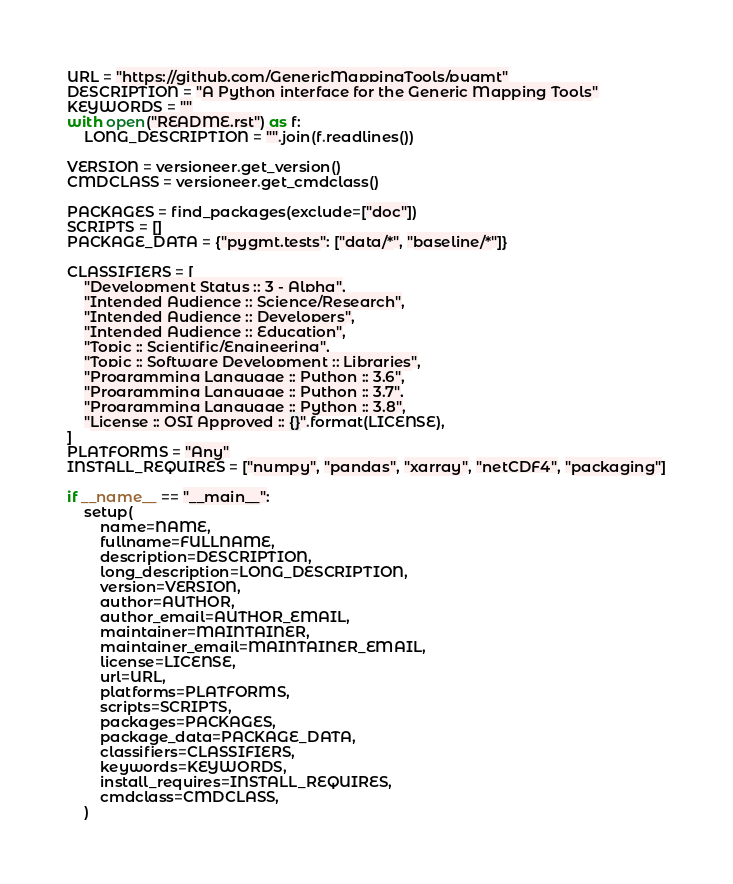<code> <loc_0><loc_0><loc_500><loc_500><_Python_>URL = "https://github.com/GenericMappingTools/pygmt"
DESCRIPTION = "A Python interface for the Generic Mapping Tools"
KEYWORDS = ""
with open("README.rst") as f:
    LONG_DESCRIPTION = "".join(f.readlines())

VERSION = versioneer.get_version()
CMDCLASS = versioneer.get_cmdclass()

PACKAGES = find_packages(exclude=["doc"])
SCRIPTS = []
PACKAGE_DATA = {"pygmt.tests": ["data/*", "baseline/*"]}

CLASSIFIERS = [
    "Development Status :: 3 - Alpha",
    "Intended Audience :: Science/Research",
    "Intended Audience :: Developers",
    "Intended Audience :: Education",
    "Topic :: Scientific/Engineering",
    "Topic :: Software Development :: Libraries",
    "Programming Language :: Python :: 3.6",
    "Programming Language :: Python :: 3.7",
    "Programming Language :: Python :: 3.8",
    "License :: OSI Approved :: {}".format(LICENSE),
]
PLATFORMS = "Any"
INSTALL_REQUIRES = ["numpy", "pandas", "xarray", "netCDF4", "packaging"]

if __name__ == "__main__":
    setup(
        name=NAME,
        fullname=FULLNAME,
        description=DESCRIPTION,
        long_description=LONG_DESCRIPTION,
        version=VERSION,
        author=AUTHOR,
        author_email=AUTHOR_EMAIL,
        maintainer=MAINTAINER,
        maintainer_email=MAINTAINER_EMAIL,
        license=LICENSE,
        url=URL,
        platforms=PLATFORMS,
        scripts=SCRIPTS,
        packages=PACKAGES,
        package_data=PACKAGE_DATA,
        classifiers=CLASSIFIERS,
        keywords=KEYWORDS,
        install_requires=INSTALL_REQUIRES,
        cmdclass=CMDCLASS,
    )
</code> 